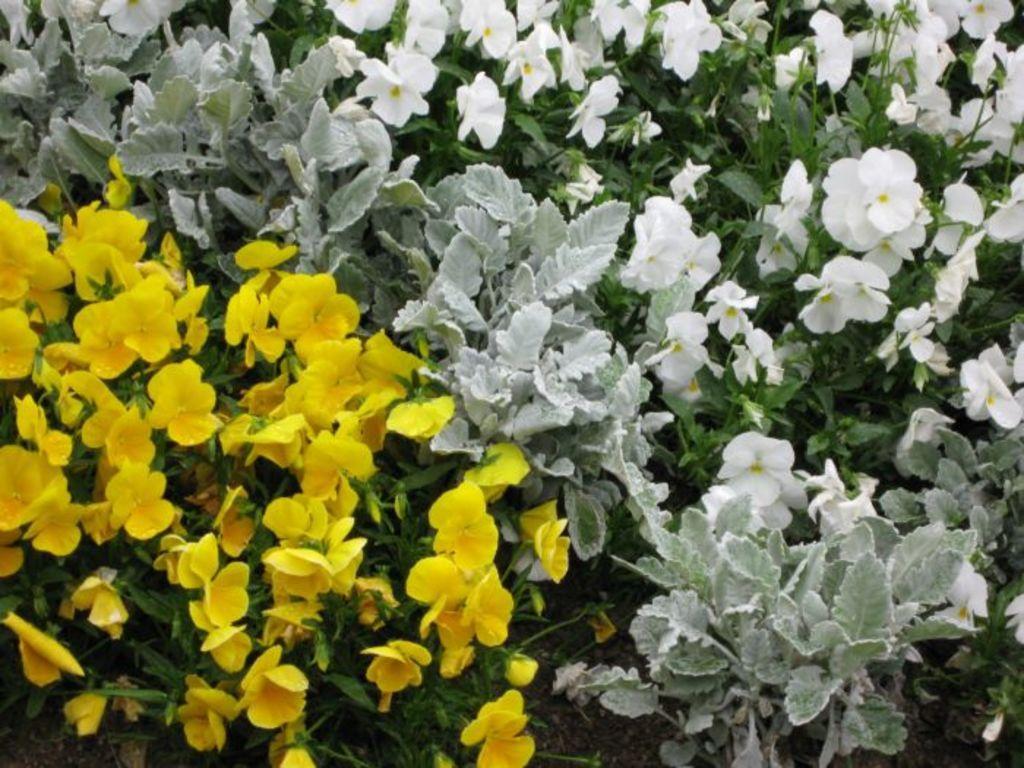Could you give a brief overview of what you see in this image? In this image we can see a bunch of flowers with some leaves. 